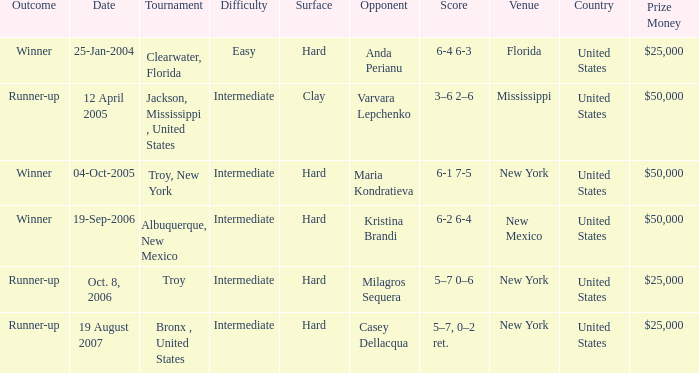What was the outcome of the game played on 19-Sep-2006? Winner. 